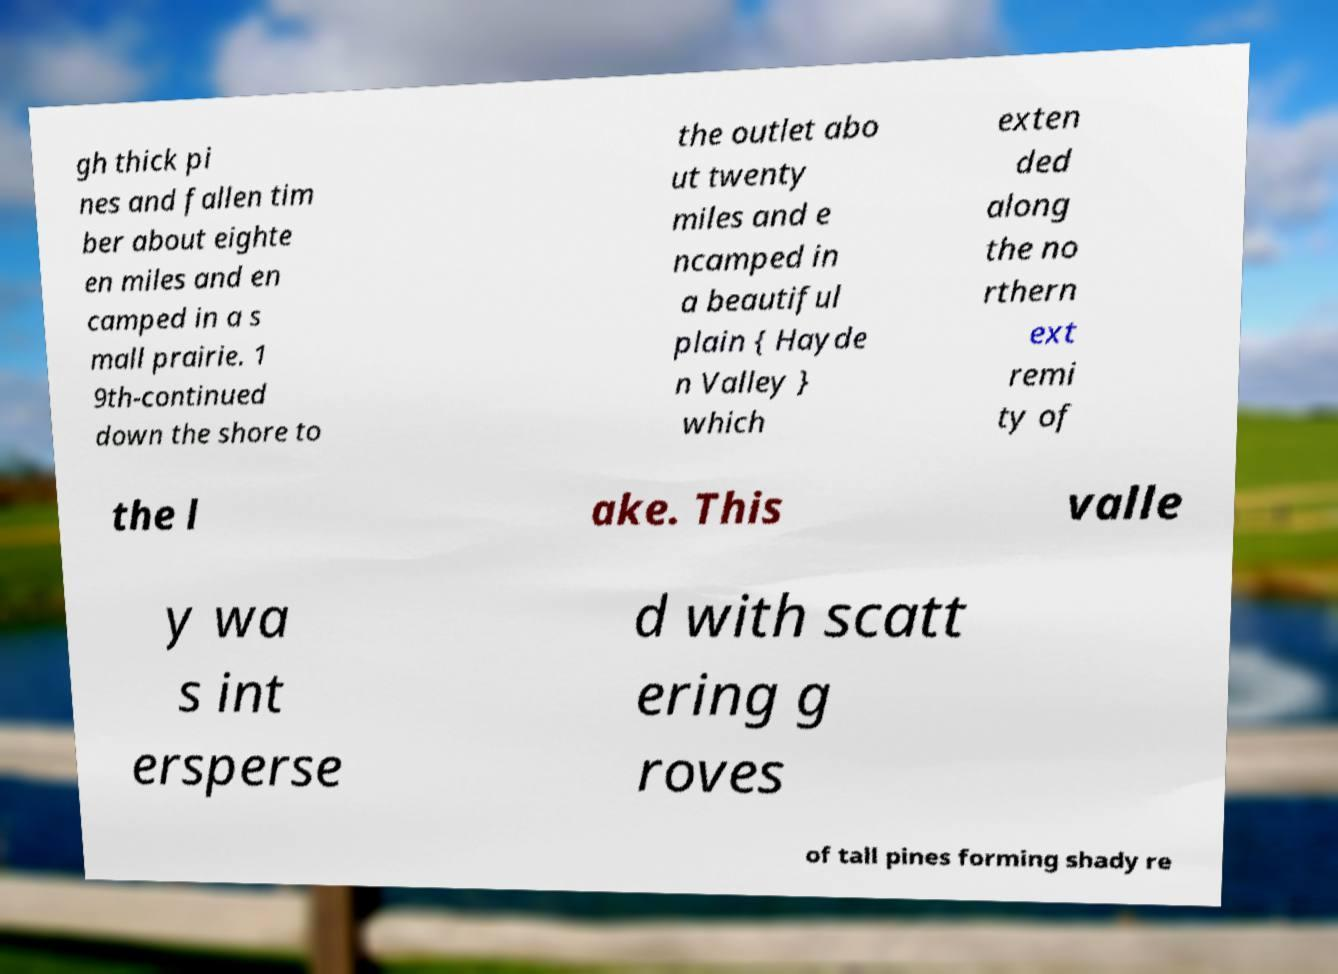Please identify and transcribe the text found in this image. gh thick pi nes and fallen tim ber about eighte en miles and en camped in a s mall prairie. 1 9th-continued down the shore to the outlet abo ut twenty miles and e ncamped in a beautiful plain { Hayde n Valley } which exten ded along the no rthern ext remi ty of the l ake. This valle y wa s int ersperse d with scatt ering g roves of tall pines forming shady re 